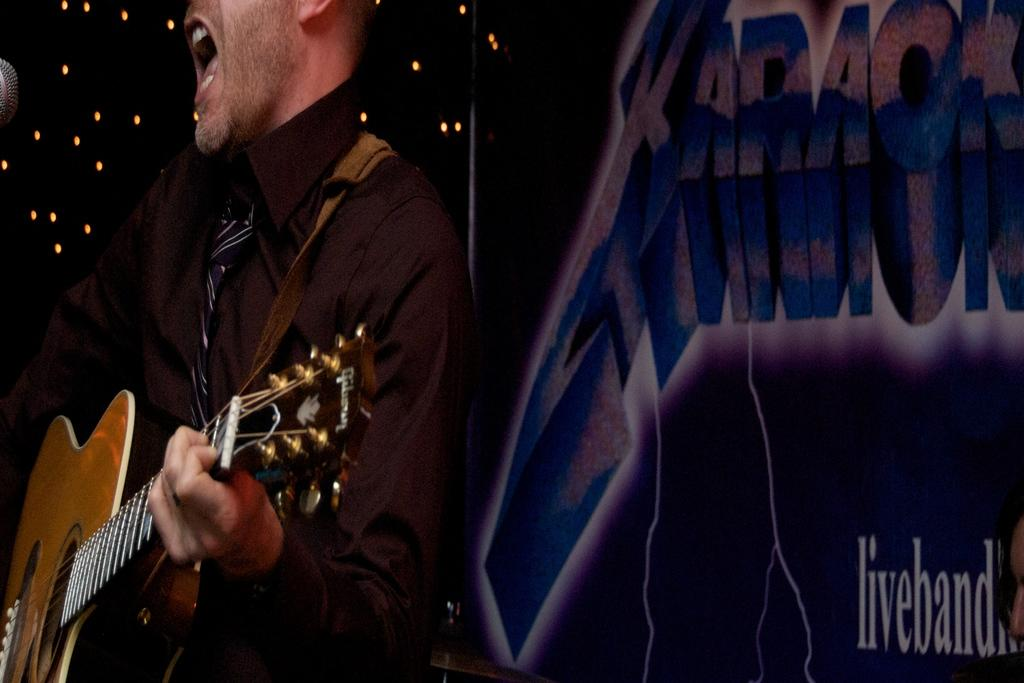What is the man in the image holding? The man is holding a guitar in his hand. What other object can be seen in the image related to performing? There is a microphone (mic) in the image. What is the title of the song the man is singing in the image? There is no indication of a song or singing in the image, so it's not possible to determine the title. 